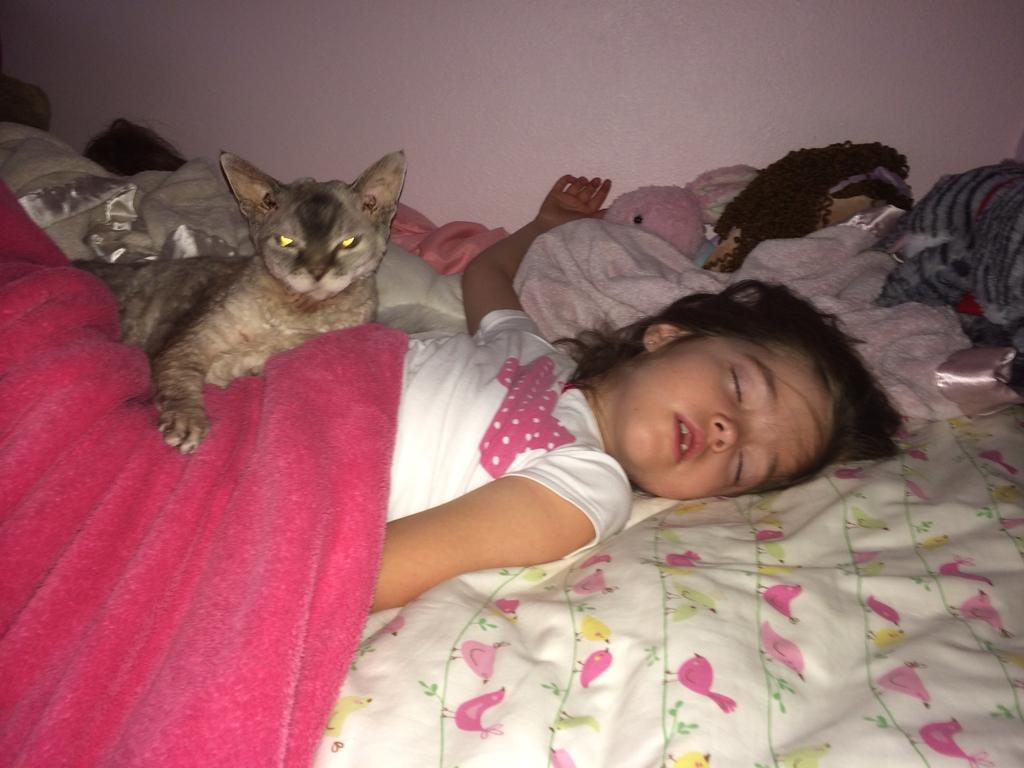What is the person in the image doing? The person is sleeping on the bed. What is the design of the bed sheet? The bed sheet has a flower design. What is placed on the bed besides the person? There is a towel and toys on the bed. What is covering the person? There is a blanket above the person. What is laying on the person? A cat is laying on the person. What can be seen in the background of the image? There is a wall in the background. What type of smoke can be seen coming from the soda in the image? A: There is no soda present in the image, so there is no smoke coming from it. 